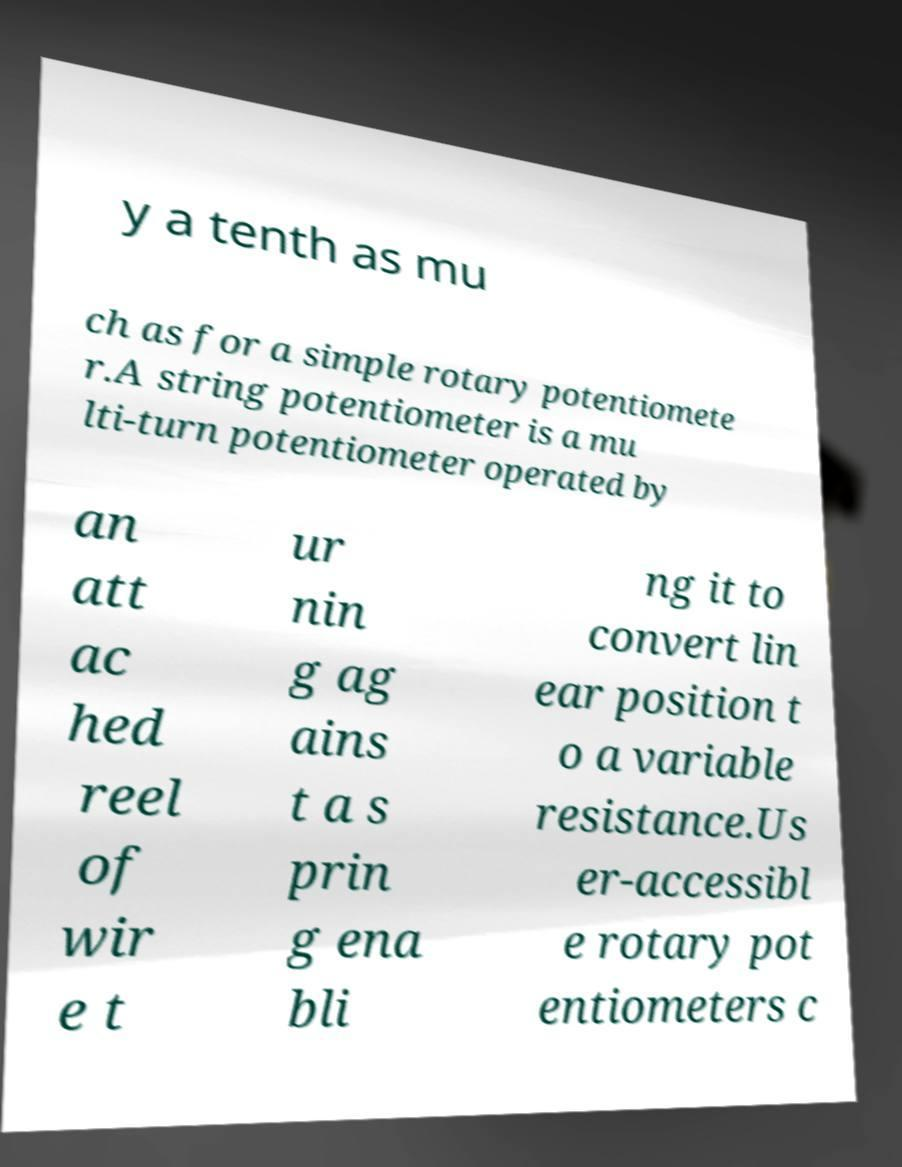There's text embedded in this image that I need extracted. Can you transcribe it verbatim? y a tenth as mu ch as for a simple rotary potentiomete r.A string potentiometer is a mu lti-turn potentiometer operated by an att ac hed reel of wir e t ur nin g ag ains t a s prin g ena bli ng it to convert lin ear position t o a variable resistance.Us er-accessibl e rotary pot entiometers c 